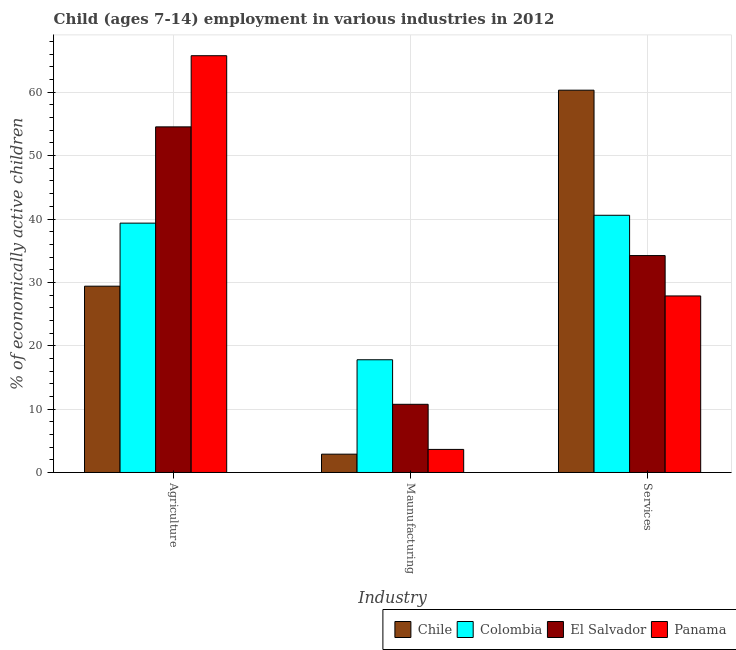How many different coloured bars are there?
Your response must be concise. 4. How many groups of bars are there?
Your answer should be very brief. 3. Are the number of bars per tick equal to the number of legend labels?
Keep it short and to the point. Yes. Are the number of bars on each tick of the X-axis equal?
Make the answer very short. Yes. How many bars are there on the 1st tick from the left?
Keep it short and to the point. 4. How many bars are there on the 1st tick from the right?
Keep it short and to the point. 4. What is the label of the 2nd group of bars from the left?
Your answer should be compact. Maunufacturing. What is the percentage of economically active children in agriculture in Colombia?
Your answer should be compact. 39.35. Across all countries, what is the maximum percentage of economically active children in manufacturing?
Your response must be concise. 17.79. Across all countries, what is the minimum percentage of economically active children in services?
Provide a short and direct response. 27.86. In which country was the percentage of economically active children in agriculture maximum?
Your answer should be compact. Panama. In which country was the percentage of economically active children in agriculture minimum?
Your answer should be compact. Chile. What is the total percentage of economically active children in agriculture in the graph?
Provide a succinct answer. 189.06. What is the difference between the percentage of economically active children in services in Chile and that in Panama?
Offer a terse response. 32.47. What is the difference between the percentage of economically active children in agriculture in Colombia and the percentage of economically active children in manufacturing in Panama?
Your answer should be very brief. 35.71. What is the average percentage of economically active children in agriculture per country?
Give a very brief answer. 47.27. What is the difference between the percentage of economically active children in manufacturing and percentage of economically active children in agriculture in Panama?
Your response must be concise. -62.13. What is the ratio of the percentage of economically active children in services in Panama to that in Chile?
Your answer should be very brief. 0.46. Is the difference between the percentage of economically active children in services in Chile and Colombia greater than the difference between the percentage of economically active children in agriculture in Chile and Colombia?
Ensure brevity in your answer.  Yes. What is the difference between the highest and the second highest percentage of economically active children in manufacturing?
Your answer should be very brief. 7.03. What is the difference between the highest and the lowest percentage of economically active children in manufacturing?
Your response must be concise. 14.9. In how many countries, is the percentage of economically active children in agriculture greater than the average percentage of economically active children in agriculture taken over all countries?
Offer a terse response. 2. Is the sum of the percentage of economically active children in manufacturing in Chile and Colombia greater than the maximum percentage of economically active children in agriculture across all countries?
Keep it short and to the point. No. What does the 1st bar from the left in Services represents?
Keep it short and to the point. Chile. What does the 4th bar from the right in Maunufacturing represents?
Your answer should be compact. Chile. Are all the bars in the graph horizontal?
Make the answer very short. No. Does the graph contain grids?
Your response must be concise. Yes. How many legend labels are there?
Your answer should be very brief. 4. How are the legend labels stacked?
Keep it short and to the point. Horizontal. What is the title of the graph?
Your response must be concise. Child (ages 7-14) employment in various industries in 2012. What is the label or title of the X-axis?
Offer a very short reply. Industry. What is the label or title of the Y-axis?
Make the answer very short. % of economically active children. What is the % of economically active children of Chile in Agriculture?
Your response must be concise. 29.4. What is the % of economically active children in Colombia in Agriculture?
Keep it short and to the point. 39.35. What is the % of economically active children in El Salvador in Agriculture?
Your response must be concise. 54.54. What is the % of economically active children in Panama in Agriculture?
Make the answer very short. 65.77. What is the % of economically active children in Chile in Maunufacturing?
Keep it short and to the point. 2.89. What is the % of economically active children in Colombia in Maunufacturing?
Make the answer very short. 17.79. What is the % of economically active children of El Salvador in Maunufacturing?
Give a very brief answer. 10.76. What is the % of economically active children of Panama in Maunufacturing?
Offer a terse response. 3.64. What is the % of economically active children of Chile in Services?
Keep it short and to the point. 60.33. What is the % of economically active children of Colombia in Services?
Ensure brevity in your answer.  40.59. What is the % of economically active children of El Salvador in Services?
Make the answer very short. 34.23. What is the % of economically active children in Panama in Services?
Your answer should be very brief. 27.86. Across all Industry, what is the maximum % of economically active children of Chile?
Provide a short and direct response. 60.33. Across all Industry, what is the maximum % of economically active children of Colombia?
Make the answer very short. 40.59. Across all Industry, what is the maximum % of economically active children of El Salvador?
Give a very brief answer. 54.54. Across all Industry, what is the maximum % of economically active children of Panama?
Provide a short and direct response. 65.77. Across all Industry, what is the minimum % of economically active children in Chile?
Your response must be concise. 2.89. Across all Industry, what is the minimum % of economically active children of Colombia?
Your answer should be very brief. 17.79. Across all Industry, what is the minimum % of economically active children of El Salvador?
Keep it short and to the point. 10.76. Across all Industry, what is the minimum % of economically active children of Panama?
Your answer should be very brief. 3.64. What is the total % of economically active children in Chile in the graph?
Keep it short and to the point. 92.62. What is the total % of economically active children in Colombia in the graph?
Offer a very short reply. 97.73. What is the total % of economically active children in El Salvador in the graph?
Your response must be concise. 99.53. What is the total % of economically active children in Panama in the graph?
Make the answer very short. 97.27. What is the difference between the % of economically active children in Chile in Agriculture and that in Maunufacturing?
Provide a short and direct response. 26.51. What is the difference between the % of economically active children in Colombia in Agriculture and that in Maunufacturing?
Provide a short and direct response. 21.56. What is the difference between the % of economically active children of El Salvador in Agriculture and that in Maunufacturing?
Give a very brief answer. 43.78. What is the difference between the % of economically active children of Panama in Agriculture and that in Maunufacturing?
Your response must be concise. 62.13. What is the difference between the % of economically active children in Chile in Agriculture and that in Services?
Provide a short and direct response. -30.93. What is the difference between the % of economically active children in Colombia in Agriculture and that in Services?
Provide a succinct answer. -1.24. What is the difference between the % of economically active children in El Salvador in Agriculture and that in Services?
Your answer should be very brief. 20.31. What is the difference between the % of economically active children of Panama in Agriculture and that in Services?
Provide a short and direct response. 37.91. What is the difference between the % of economically active children in Chile in Maunufacturing and that in Services?
Ensure brevity in your answer.  -57.44. What is the difference between the % of economically active children in Colombia in Maunufacturing and that in Services?
Your answer should be very brief. -22.8. What is the difference between the % of economically active children in El Salvador in Maunufacturing and that in Services?
Your answer should be compact. -23.47. What is the difference between the % of economically active children in Panama in Maunufacturing and that in Services?
Keep it short and to the point. -24.22. What is the difference between the % of economically active children in Chile in Agriculture and the % of economically active children in Colombia in Maunufacturing?
Make the answer very short. 11.61. What is the difference between the % of economically active children of Chile in Agriculture and the % of economically active children of El Salvador in Maunufacturing?
Offer a very short reply. 18.64. What is the difference between the % of economically active children in Chile in Agriculture and the % of economically active children in Panama in Maunufacturing?
Offer a very short reply. 25.76. What is the difference between the % of economically active children of Colombia in Agriculture and the % of economically active children of El Salvador in Maunufacturing?
Keep it short and to the point. 28.59. What is the difference between the % of economically active children of Colombia in Agriculture and the % of economically active children of Panama in Maunufacturing?
Keep it short and to the point. 35.71. What is the difference between the % of economically active children of El Salvador in Agriculture and the % of economically active children of Panama in Maunufacturing?
Keep it short and to the point. 50.9. What is the difference between the % of economically active children in Chile in Agriculture and the % of economically active children in Colombia in Services?
Ensure brevity in your answer.  -11.19. What is the difference between the % of economically active children in Chile in Agriculture and the % of economically active children in El Salvador in Services?
Your response must be concise. -4.83. What is the difference between the % of economically active children in Chile in Agriculture and the % of economically active children in Panama in Services?
Give a very brief answer. 1.54. What is the difference between the % of economically active children in Colombia in Agriculture and the % of economically active children in El Salvador in Services?
Provide a short and direct response. 5.12. What is the difference between the % of economically active children in Colombia in Agriculture and the % of economically active children in Panama in Services?
Ensure brevity in your answer.  11.49. What is the difference between the % of economically active children in El Salvador in Agriculture and the % of economically active children in Panama in Services?
Make the answer very short. 26.68. What is the difference between the % of economically active children of Chile in Maunufacturing and the % of economically active children of Colombia in Services?
Your response must be concise. -37.7. What is the difference between the % of economically active children in Chile in Maunufacturing and the % of economically active children in El Salvador in Services?
Offer a very short reply. -31.34. What is the difference between the % of economically active children of Chile in Maunufacturing and the % of economically active children of Panama in Services?
Your response must be concise. -24.97. What is the difference between the % of economically active children of Colombia in Maunufacturing and the % of economically active children of El Salvador in Services?
Provide a short and direct response. -16.44. What is the difference between the % of economically active children in Colombia in Maunufacturing and the % of economically active children in Panama in Services?
Your response must be concise. -10.07. What is the difference between the % of economically active children of El Salvador in Maunufacturing and the % of economically active children of Panama in Services?
Keep it short and to the point. -17.1. What is the average % of economically active children in Chile per Industry?
Ensure brevity in your answer.  30.87. What is the average % of economically active children of Colombia per Industry?
Ensure brevity in your answer.  32.58. What is the average % of economically active children in El Salvador per Industry?
Offer a very short reply. 33.18. What is the average % of economically active children of Panama per Industry?
Make the answer very short. 32.42. What is the difference between the % of economically active children of Chile and % of economically active children of Colombia in Agriculture?
Your response must be concise. -9.95. What is the difference between the % of economically active children of Chile and % of economically active children of El Salvador in Agriculture?
Your answer should be compact. -25.14. What is the difference between the % of economically active children in Chile and % of economically active children in Panama in Agriculture?
Offer a very short reply. -36.37. What is the difference between the % of economically active children in Colombia and % of economically active children in El Salvador in Agriculture?
Provide a succinct answer. -15.19. What is the difference between the % of economically active children in Colombia and % of economically active children in Panama in Agriculture?
Your answer should be very brief. -26.42. What is the difference between the % of economically active children in El Salvador and % of economically active children in Panama in Agriculture?
Provide a short and direct response. -11.23. What is the difference between the % of economically active children of Chile and % of economically active children of Colombia in Maunufacturing?
Ensure brevity in your answer.  -14.9. What is the difference between the % of economically active children in Chile and % of economically active children in El Salvador in Maunufacturing?
Make the answer very short. -7.87. What is the difference between the % of economically active children in Chile and % of economically active children in Panama in Maunufacturing?
Offer a terse response. -0.75. What is the difference between the % of economically active children of Colombia and % of economically active children of El Salvador in Maunufacturing?
Ensure brevity in your answer.  7.03. What is the difference between the % of economically active children in Colombia and % of economically active children in Panama in Maunufacturing?
Give a very brief answer. 14.15. What is the difference between the % of economically active children of El Salvador and % of economically active children of Panama in Maunufacturing?
Offer a very short reply. 7.12. What is the difference between the % of economically active children in Chile and % of economically active children in Colombia in Services?
Your response must be concise. 19.74. What is the difference between the % of economically active children in Chile and % of economically active children in El Salvador in Services?
Keep it short and to the point. 26.1. What is the difference between the % of economically active children in Chile and % of economically active children in Panama in Services?
Offer a terse response. 32.47. What is the difference between the % of economically active children of Colombia and % of economically active children of El Salvador in Services?
Keep it short and to the point. 6.36. What is the difference between the % of economically active children in Colombia and % of economically active children in Panama in Services?
Offer a very short reply. 12.73. What is the difference between the % of economically active children of El Salvador and % of economically active children of Panama in Services?
Offer a very short reply. 6.37. What is the ratio of the % of economically active children of Chile in Agriculture to that in Maunufacturing?
Your answer should be compact. 10.17. What is the ratio of the % of economically active children of Colombia in Agriculture to that in Maunufacturing?
Ensure brevity in your answer.  2.21. What is the ratio of the % of economically active children of El Salvador in Agriculture to that in Maunufacturing?
Your answer should be very brief. 5.07. What is the ratio of the % of economically active children of Panama in Agriculture to that in Maunufacturing?
Make the answer very short. 18.07. What is the ratio of the % of economically active children of Chile in Agriculture to that in Services?
Give a very brief answer. 0.49. What is the ratio of the % of economically active children of Colombia in Agriculture to that in Services?
Give a very brief answer. 0.97. What is the ratio of the % of economically active children in El Salvador in Agriculture to that in Services?
Provide a succinct answer. 1.59. What is the ratio of the % of economically active children in Panama in Agriculture to that in Services?
Offer a terse response. 2.36. What is the ratio of the % of economically active children of Chile in Maunufacturing to that in Services?
Give a very brief answer. 0.05. What is the ratio of the % of economically active children of Colombia in Maunufacturing to that in Services?
Keep it short and to the point. 0.44. What is the ratio of the % of economically active children of El Salvador in Maunufacturing to that in Services?
Provide a succinct answer. 0.31. What is the ratio of the % of economically active children of Panama in Maunufacturing to that in Services?
Give a very brief answer. 0.13. What is the difference between the highest and the second highest % of economically active children of Chile?
Your response must be concise. 30.93. What is the difference between the highest and the second highest % of economically active children in Colombia?
Offer a terse response. 1.24. What is the difference between the highest and the second highest % of economically active children in El Salvador?
Provide a short and direct response. 20.31. What is the difference between the highest and the second highest % of economically active children in Panama?
Give a very brief answer. 37.91. What is the difference between the highest and the lowest % of economically active children in Chile?
Your answer should be compact. 57.44. What is the difference between the highest and the lowest % of economically active children of Colombia?
Keep it short and to the point. 22.8. What is the difference between the highest and the lowest % of economically active children of El Salvador?
Your response must be concise. 43.78. What is the difference between the highest and the lowest % of economically active children in Panama?
Offer a terse response. 62.13. 